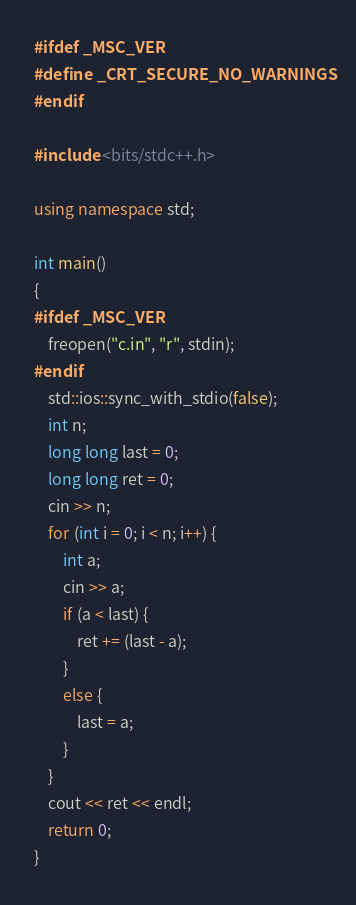Convert code to text. <code><loc_0><loc_0><loc_500><loc_500><_C++_>#ifdef _MSC_VER
#define _CRT_SECURE_NO_WARNINGS
#endif

#include <bits/stdc++.h>

using namespace std;

int main()
{
#ifdef _MSC_VER
	freopen("c.in", "r", stdin);
#endif
	std::ios::sync_with_stdio(false);
	int n;
	long long last = 0;
	long long ret = 0;
	cin >> n;
	for (int i = 0; i < n; i++) {
		int a;
		cin >> a;
		if (a < last) {
			ret += (last - a);
		}
		else {
			last = a;
		}
	}
	cout << ret << endl;
	return 0;
}
</code> 